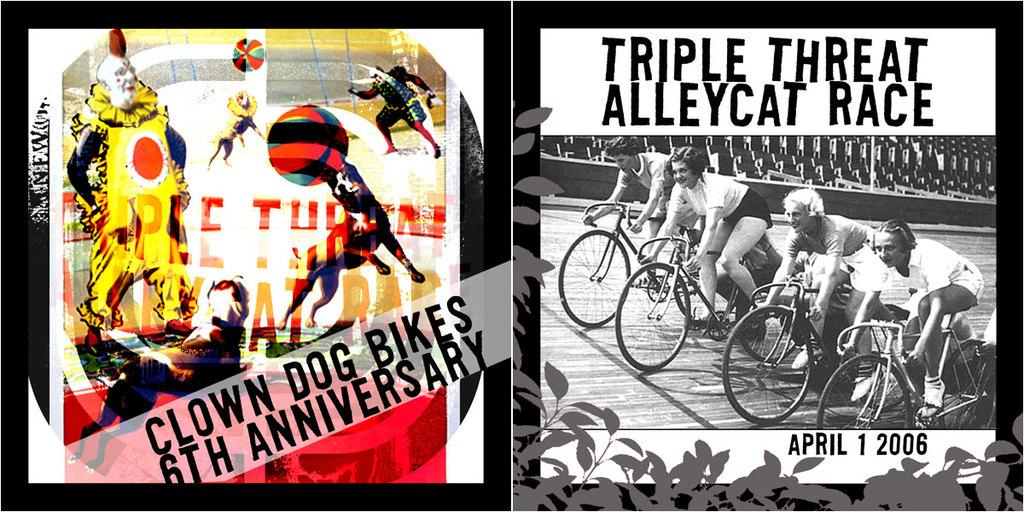Provide a one-sentence caption for the provided image. The Triple Threat Alley Race is on April first 2006. 